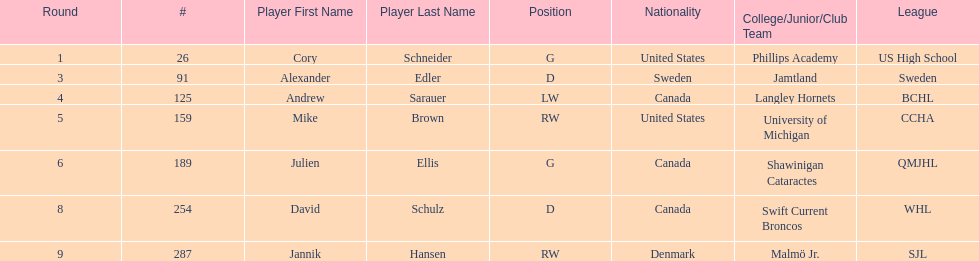What number of players have canada listed as their nationality? 3. 